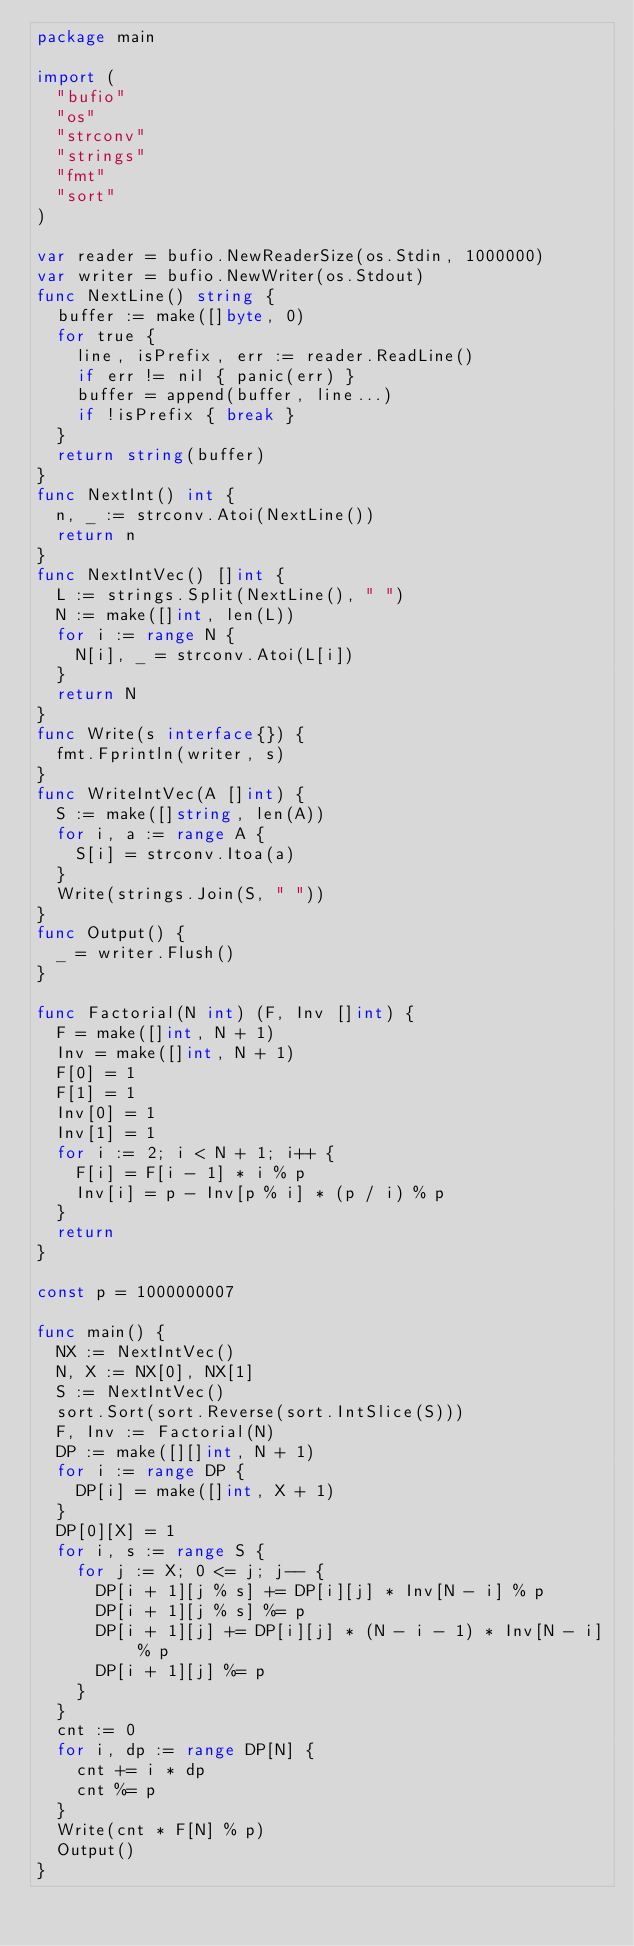<code> <loc_0><loc_0><loc_500><loc_500><_Go_>package main

import (
  "bufio"
  "os"
  "strconv"
  "strings"
  "fmt"
  "sort"
)

var reader = bufio.NewReaderSize(os.Stdin, 1000000)
var writer = bufio.NewWriter(os.Stdout)
func NextLine() string {
  buffer := make([]byte, 0)
  for true {
    line, isPrefix, err := reader.ReadLine()
    if err != nil { panic(err) }
    buffer = append(buffer, line...)
    if !isPrefix { break }
  }
  return string(buffer)
}
func NextInt() int {
  n, _ := strconv.Atoi(NextLine())
  return n
}
func NextIntVec() []int {
  L := strings.Split(NextLine(), " ")
  N := make([]int, len(L))
  for i := range N {
    N[i], _ = strconv.Atoi(L[i])
  }
  return N
}
func Write(s interface{}) {
  fmt.Fprintln(writer, s)
}
func WriteIntVec(A []int) {
  S := make([]string, len(A))
  for i, a := range A {
    S[i] = strconv.Itoa(a)
  }
  Write(strings.Join(S, " "))
}
func Output() {
  _ = writer.Flush()
}

func Factorial(N int) (F, Inv []int) {
  F = make([]int, N + 1)
  Inv = make([]int, N + 1)
  F[0] = 1
  F[1] = 1
  Inv[0] = 1
  Inv[1] = 1
  for i := 2; i < N + 1; i++ {
    F[i] = F[i - 1] * i % p
    Inv[i] = p - Inv[p % i] * (p / i) % p
  }
  return
}

const p = 1000000007

func main() {
  NX := NextIntVec()
  N, X := NX[0], NX[1]
  S := NextIntVec()
  sort.Sort(sort.Reverse(sort.IntSlice(S)))
  F, Inv := Factorial(N)
  DP := make([][]int, N + 1)
  for i := range DP {
    DP[i] = make([]int, X + 1)
  }
  DP[0][X] = 1
  for i, s := range S {
    for j := X; 0 <= j; j-- {
      DP[i + 1][j % s] += DP[i][j] * Inv[N - i] % p
      DP[i + 1][j % s] %= p
      DP[i + 1][j] += DP[i][j] * (N - i - 1) * Inv[N - i] % p
      DP[i + 1][j] %= p
    }
  }
  cnt := 0
  for i, dp := range DP[N] {
    cnt += i * dp
    cnt %= p
  }
  Write(cnt * F[N] % p)
  Output()
}</code> 